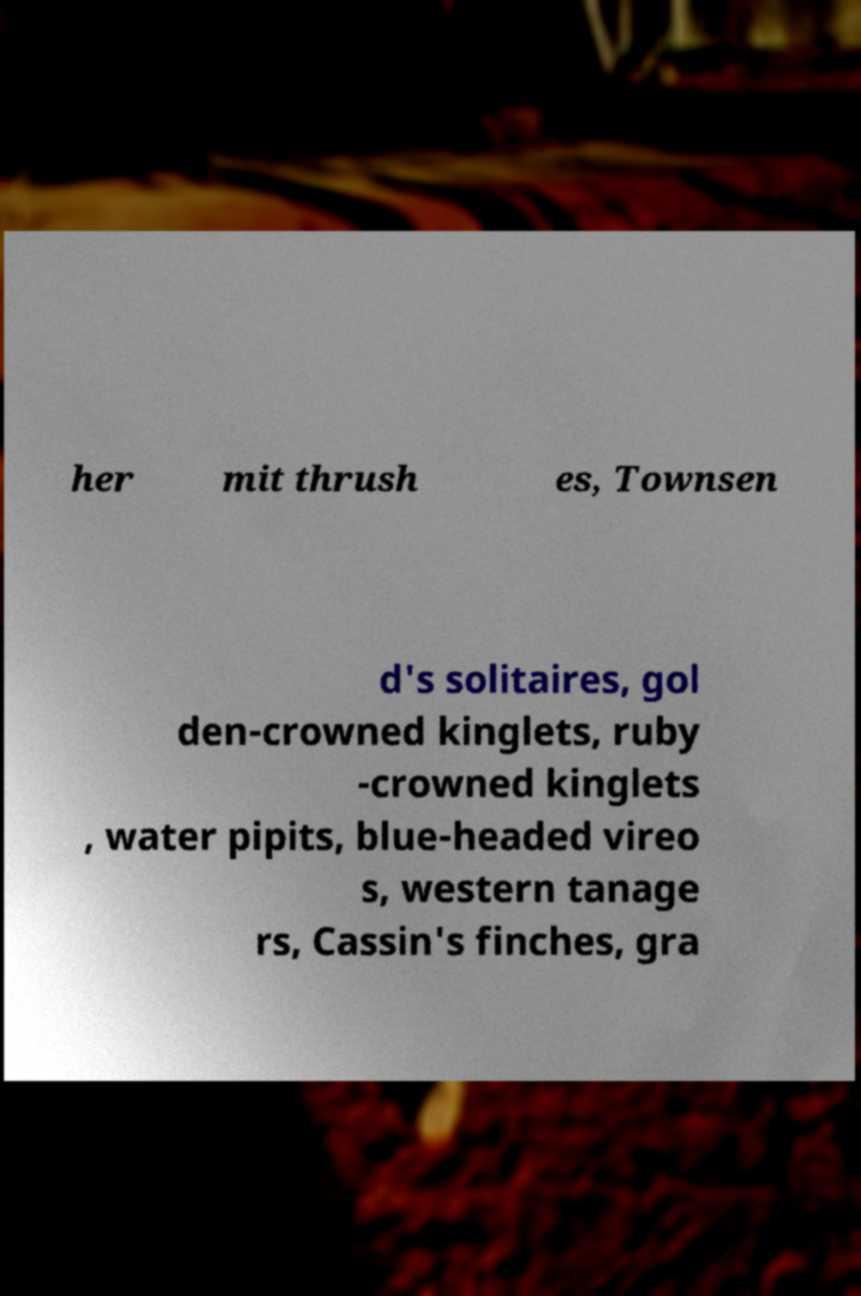For documentation purposes, I need the text within this image transcribed. Could you provide that? her mit thrush es, Townsen d's solitaires, gol den-crowned kinglets, ruby -crowned kinglets , water pipits, blue-headed vireo s, western tanage rs, Cassin's finches, gra 